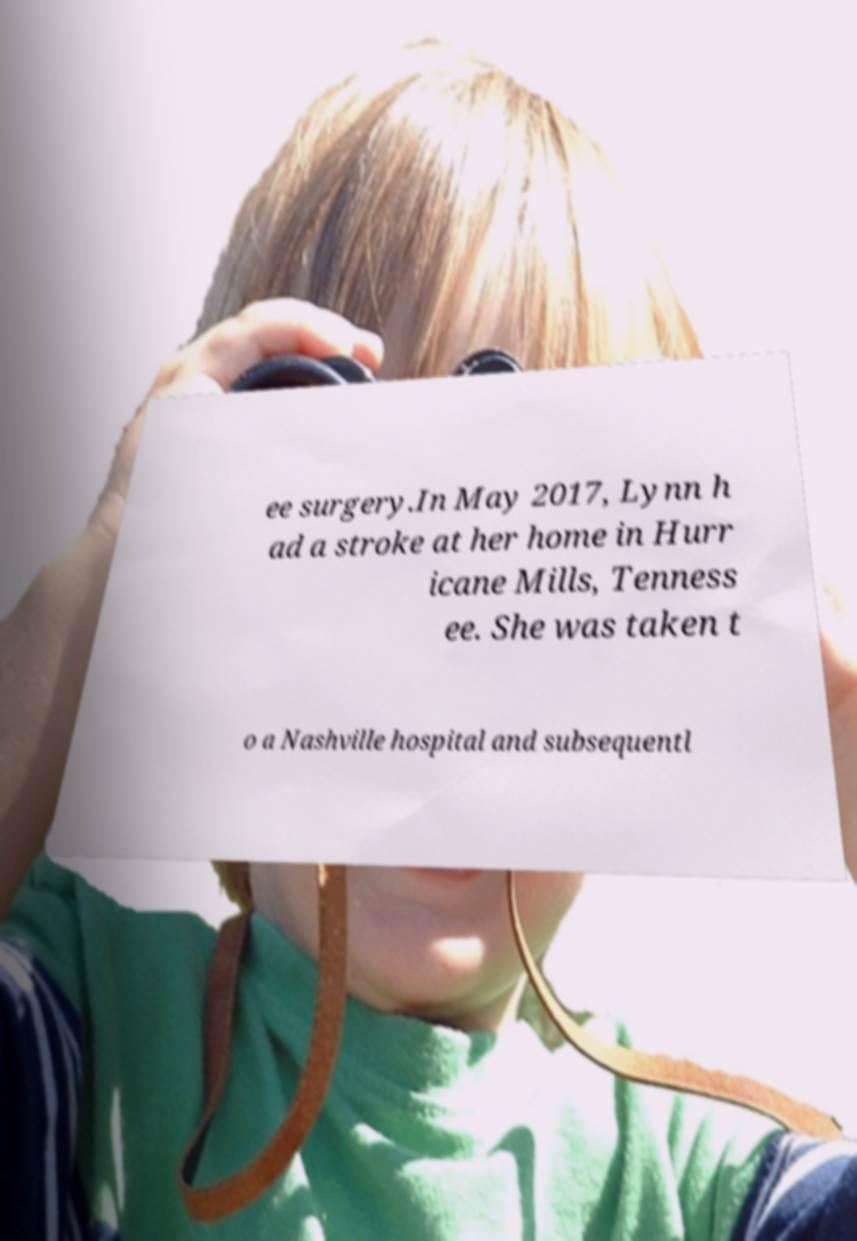Could you extract and type out the text from this image? ee surgery.In May 2017, Lynn h ad a stroke at her home in Hurr icane Mills, Tenness ee. She was taken t o a Nashville hospital and subsequentl 